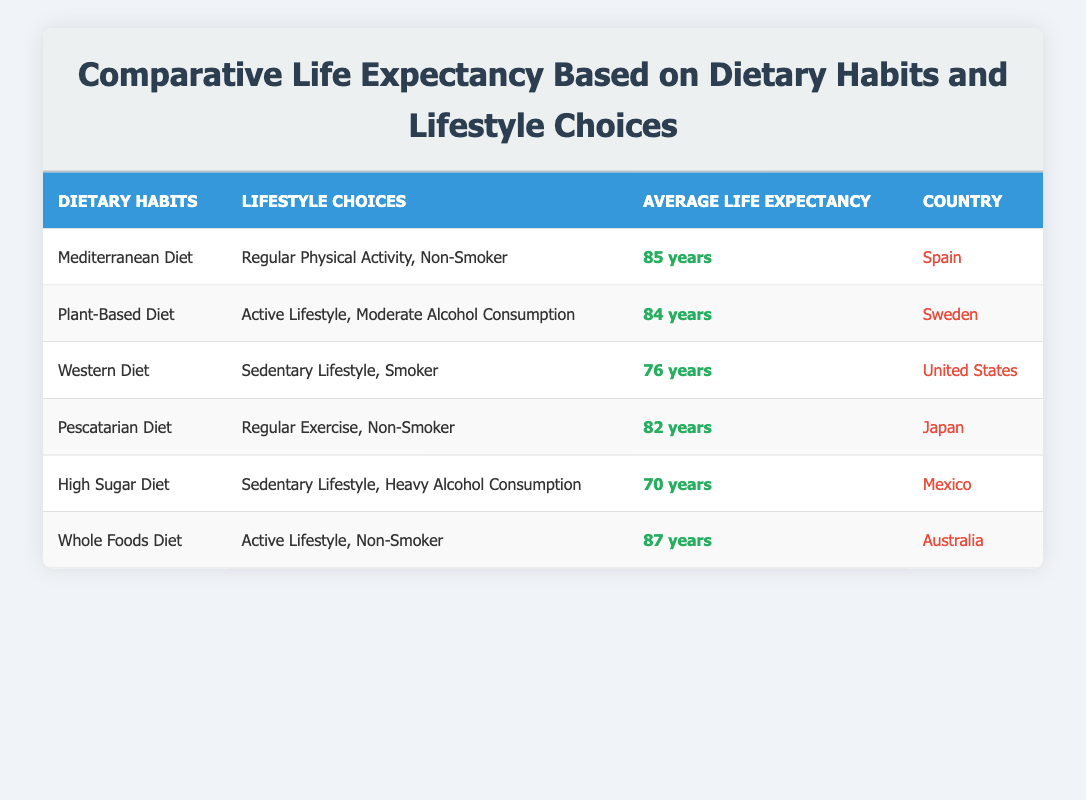What is the average life expectancy for individuals following a Mediterranean diet in Spain? The table shows that the average life expectancy for individuals following a Mediterranean diet in Spain is listed as 85 years.
Answer: 85 years How many countries are represented in this table? The table includes data from six different countries: Spain, Sweden, United States, Japan, Mexico, and Australia. Therefore, there are a total of 6 countries represented.
Answer: 6 countries What is the average life expectancy for those on a Whole Foods Diet compared to those on a High Sugar Diet? The average life expectancy for individuals on a Whole Foods Diet is 87 years, while for those on a High Sugar Diet it is 70 years. The difference between them is 87 - 70 = 17 years.
Answer: 17 years True or False: A Pescatarian diet leads to a life expectancy of at least 80 years. The table states that the average life expectancy for individuals following a Pescatarian diet in Japan is 82 years, which is greater than 80 years. Therefore, the answer is True.
Answer: True Which dietary habit has the highest average life expectancy, and what is that expectancy? The Whole Foods Diet has the highest average life expectancy at 87 years, according to the table.
Answer: Whole Foods Diet, 87 years How does the life expectancy of individuals following a Western diet compare to those on a Plant-Based diet? The average life expectancy for individuals on a Western diet is 76 years, while for those on a Plant-Based diet it is 84 years. This shows that the life expectancy for Plant-Based diet adherents is 84 - 76 = 8 years higher than that of Western diet adherents.
Answer: 8 years What lifestyle choice correlates with the highest life expectancy in this table? The Whole Foods Diet with an active lifestyle and non-smoker lifestyle choice represents the highest life expectancy at 87 years. Therefore, the lifestyle choice is "Active Lifestyle, Non-Smoker."
Answer: Active Lifestyle, Non-Smoker What is the life expectancy of individuals in Mexico following a High Sugar Diet? According to the table, individuals in Mexico following a High Sugar Diet have an average life expectancy of 70 years.
Answer: 70 years True or False: All listed diets with non-smokers have a higher average life expectancy than those with smokers. In the table, individuals on Mediterranean, Pescatarian, and Whole Foods diets (all non-smokers) have average life expectancies of 85, 82, and 87 years respectively. However, the Western diet (smoker) has an average of 76 years, and the high sugar diet (sedentary lifestyle, heavy alcohol) has an average of 70 years. Therefore, the statement is True since all non-smoker diets show higher life expectancies than smokers.
Answer: True 